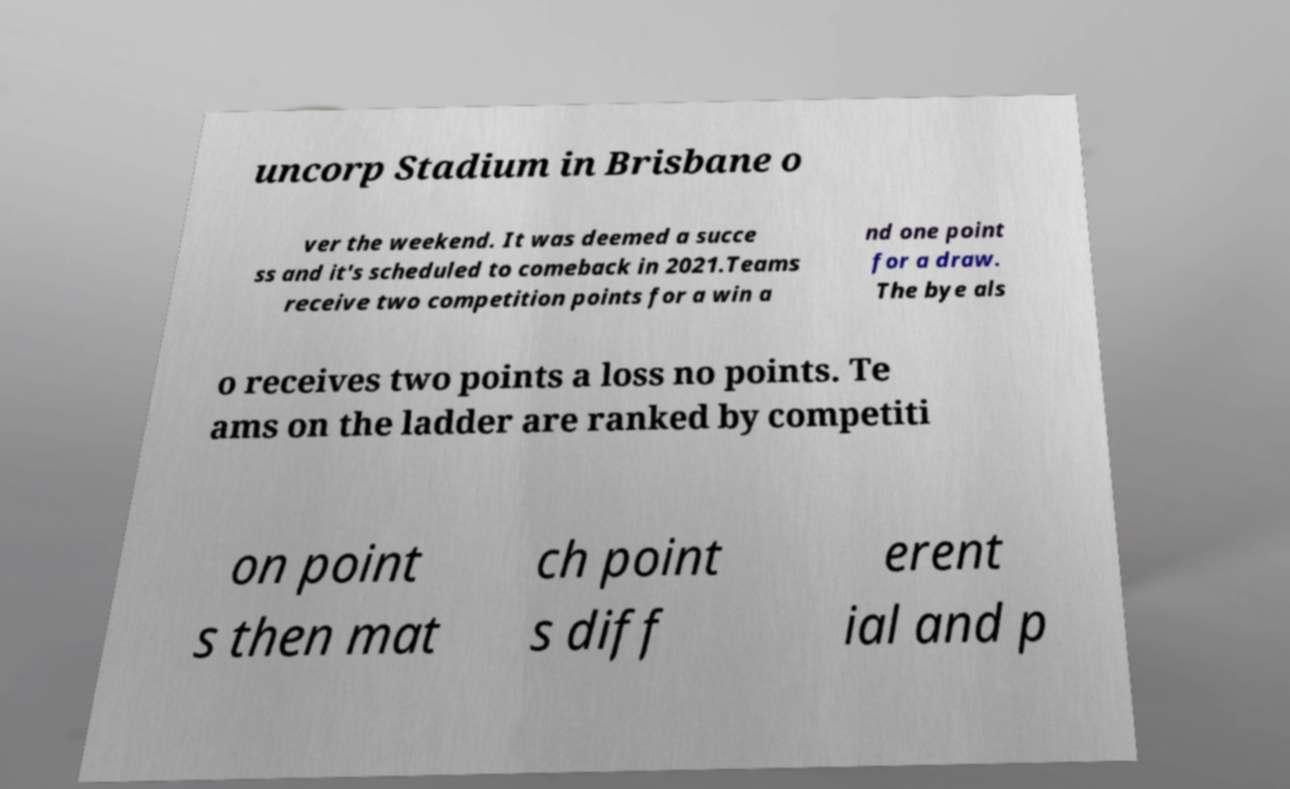Please identify and transcribe the text found in this image. uncorp Stadium in Brisbane o ver the weekend. It was deemed a succe ss and it's scheduled to comeback in 2021.Teams receive two competition points for a win a nd one point for a draw. The bye als o receives two points a loss no points. Te ams on the ladder are ranked by competiti on point s then mat ch point s diff erent ial and p 